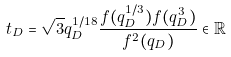<formula> <loc_0><loc_0><loc_500><loc_500>t _ { D } = \sqrt { 3 } q _ { D } ^ { 1 / 1 8 } \frac { f ( q _ { D } ^ { 1 / 3 } ) f ( q _ { D } ^ { 3 } ) } { f ^ { 2 } ( q _ { D } ) } \in \mathbb { R }</formula> 